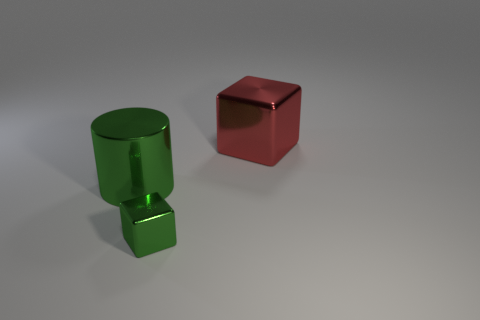Add 2 small yellow things. How many objects exist? 5 Subtract all cylinders. How many objects are left? 2 Subtract all red metal things. Subtract all big red cubes. How many objects are left? 1 Add 3 big metal things. How many big metal things are left? 5 Add 3 small metallic things. How many small metallic things exist? 4 Subtract 0 red balls. How many objects are left? 3 